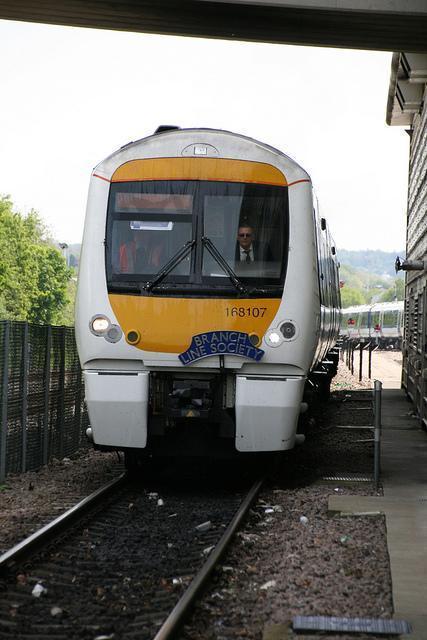How many trains are there?
Give a very brief answer. 2. 